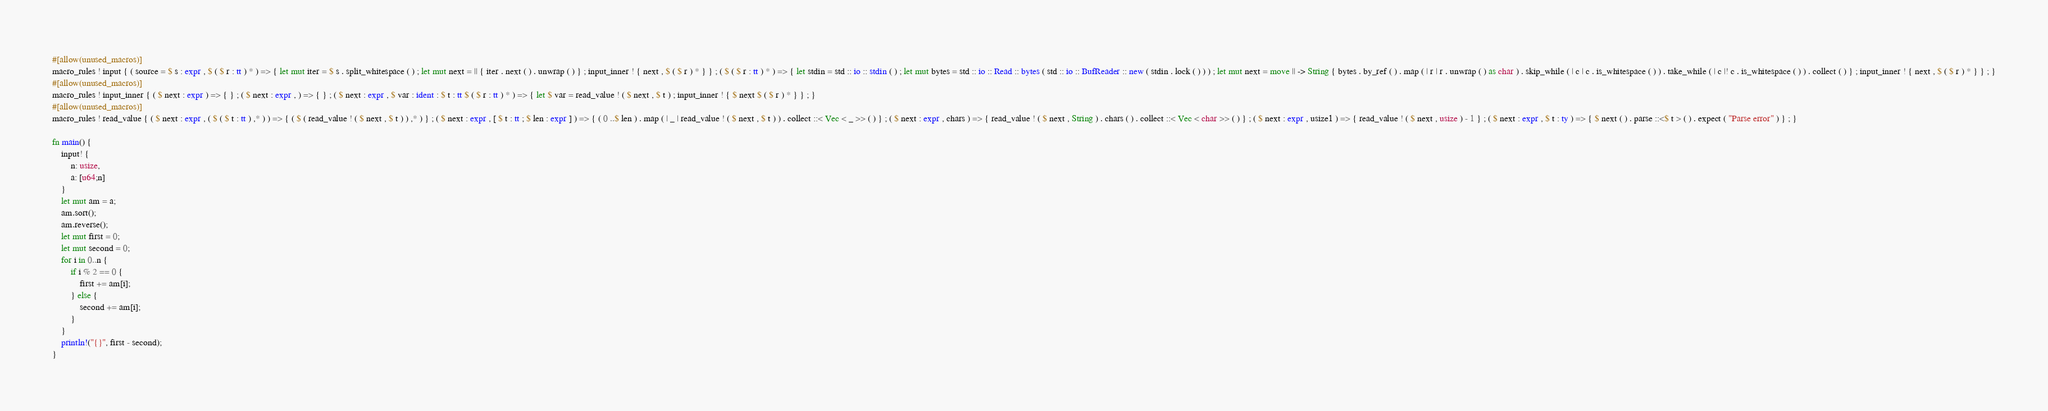Convert code to text. <code><loc_0><loc_0><loc_500><loc_500><_Rust_>#[allow(unused_macros)]
macro_rules ! input { ( source = $ s : expr , $ ( $ r : tt ) * ) => { let mut iter = $ s . split_whitespace ( ) ; let mut next = || { iter . next ( ) . unwrap ( ) } ; input_inner ! { next , $ ( $ r ) * } } ; ( $ ( $ r : tt ) * ) => { let stdin = std :: io :: stdin ( ) ; let mut bytes = std :: io :: Read :: bytes ( std :: io :: BufReader :: new ( stdin . lock ( ) ) ) ; let mut next = move || -> String { bytes . by_ref ( ) . map ( | r | r . unwrap ( ) as char ) . skip_while ( | c | c . is_whitespace ( ) ) . take_while ( | c |! c . is_whitespace ( ) ) . collect ( ) } ; input_inner ! { next , $ ( $ r ) * } } ; }
#[allow(unused_macros)]
macro_rules ! input_inner { ( $ next : expr ) => { } ; ( $ next : expr , ) => { } ; ( $ next : expr , $ var : ident : $ t : tt $ ( $ r : tt ) * ) => { let $ var = read_value ! ( $ next , $ t ) ; input_inner ! { $ next $ ( $ r ) * } } ; }
#[allow(unused_macros)]
macro_rules ! read_value { ( $ next : expr , ( $ ( $ t : tt ) ,* ) ) => { ( $ ( read_value ! ( $ next , $ t ) ) ,* ) } ; ( $ next : expr , [ $ t : tt ; $ len : expr ] ) => { ( 0 ..$ len ) . map ( | _ | read_value ! ( $ next , $ t ) ) . collect ::< Vec < _ >> ( ) } ; ( $ next : expr , chars ) => { read_value ! ( $ next , String ) . chars ( ) . collect ::< Vec < char >> ( ) } ; ( $ next : expr , usize1 ) => { read_value ! ( $ next , usize ) - 1 } ; ( $ next : expr , $ t : ty ) => { $ next ( ) . parse ::<$ t > ( ) . expect ( "Parse error" ) } ; }

fn main() {
    input! {
        n: usize,
        a: [u64;n]
    }
    let mut am = a;
    am.sort();
    am.reverse();
    let mut first = 0;
    let mut second = 0;
    for i in 0..n {
        if i % 2 == 0 {
            first += am[i];
        } else {
            second += am[i];
        }
    }
    println!("{}", first - second);
}</code> 